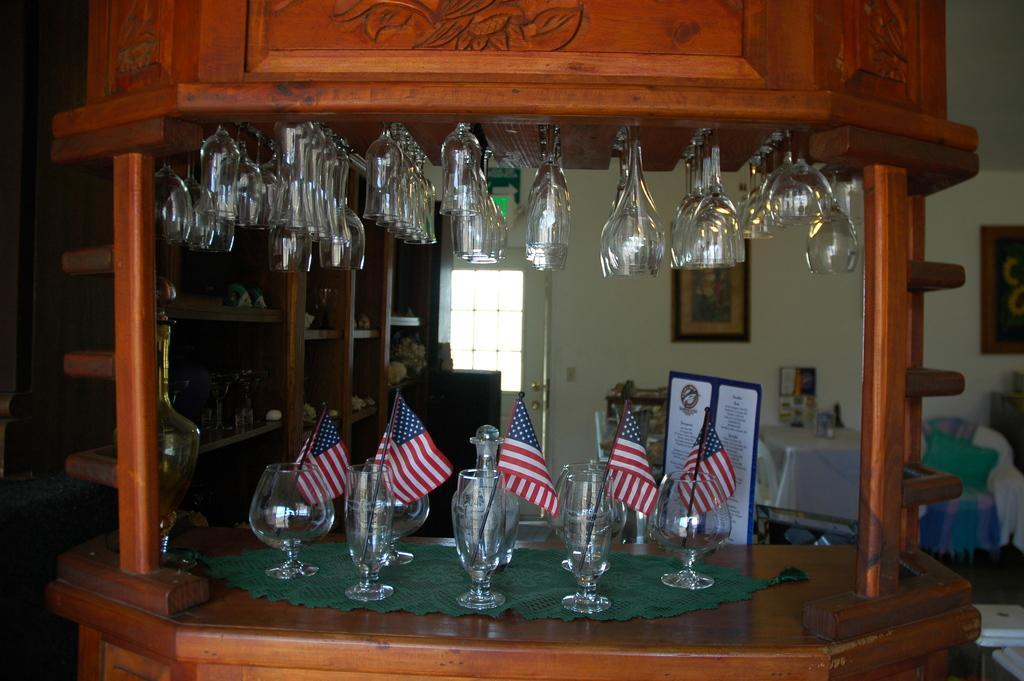Can you describe this image briefly? In this image we can see many glasses. There are many glasses placed on the tables and racks. There are few photos on the wall in the image. There are few tables and chairs in the image. 